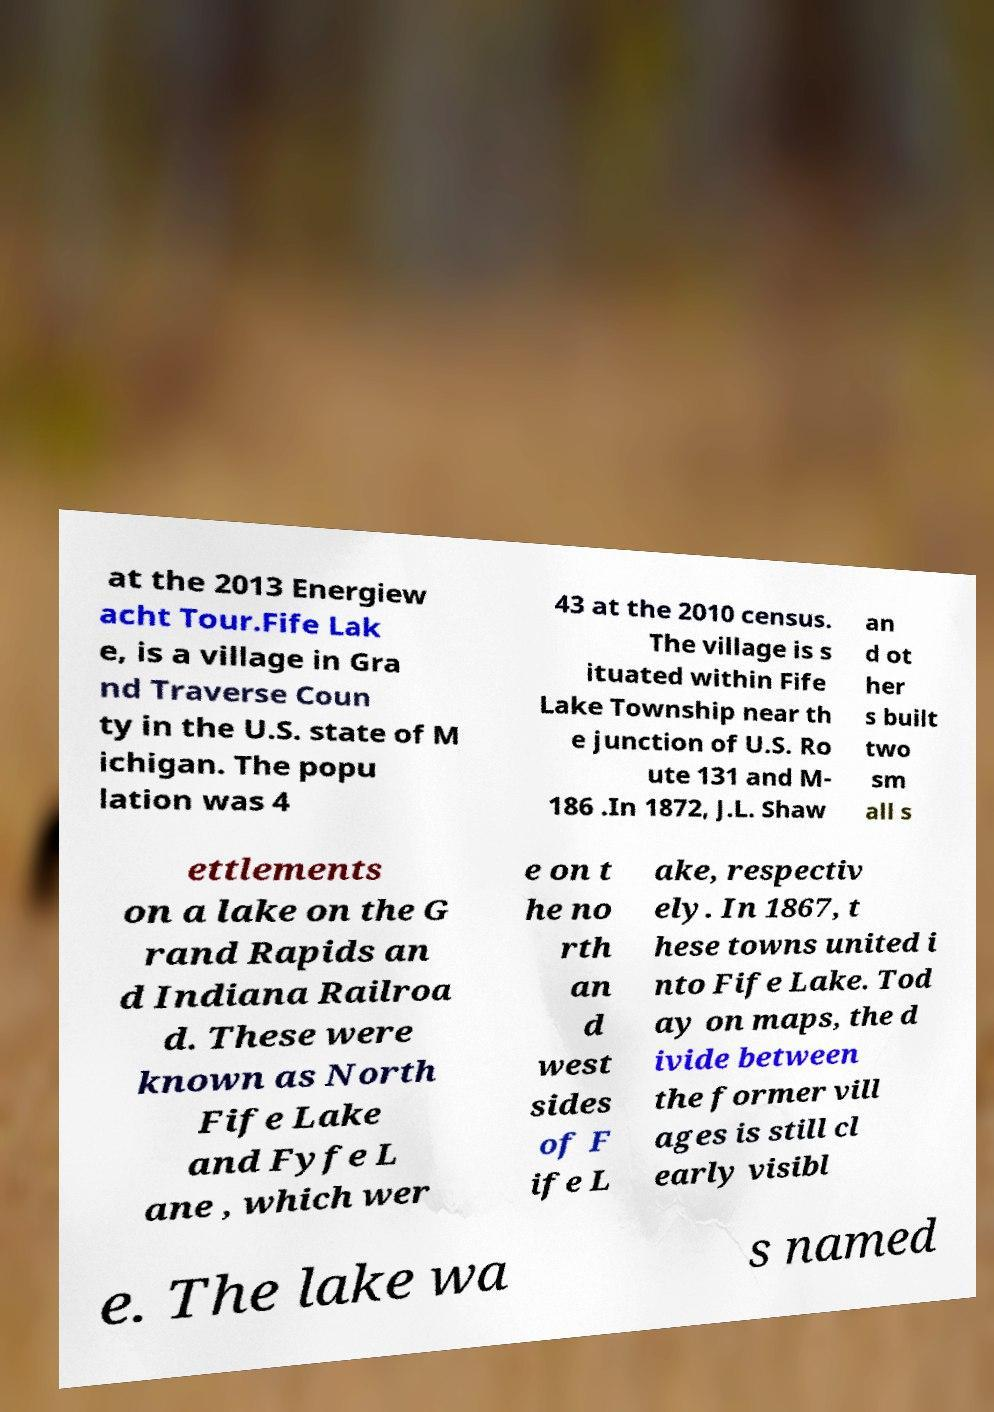Please identify and transcribe the text found in this image. at the 2013 Energiew acht Tour.Fife Lak e, is a village in Gra nd Traverse Coun ty in the U.S. state of M ichigan. The popu lation was 4 43 at the 2010 census. The village is s ituated within Fife Lake Township near th e junction of U.S. Ro ute 131 and M- 186 .In 1872, J.L. Shaw an d ot her s built two sm all s ettlements on a lake on the G rand Rapids an d Indiana Railroa d. These were known as North Fife Lake and Fyfe L ane , which wer e on t he no rth an d west sides of F ife L ake, respectiv ely. In 1867, t hese towns united i nto Fife Lake. Tod ay on maps, the d ivide between the former vill ages is still cl early visibl e. The lake wa s named 